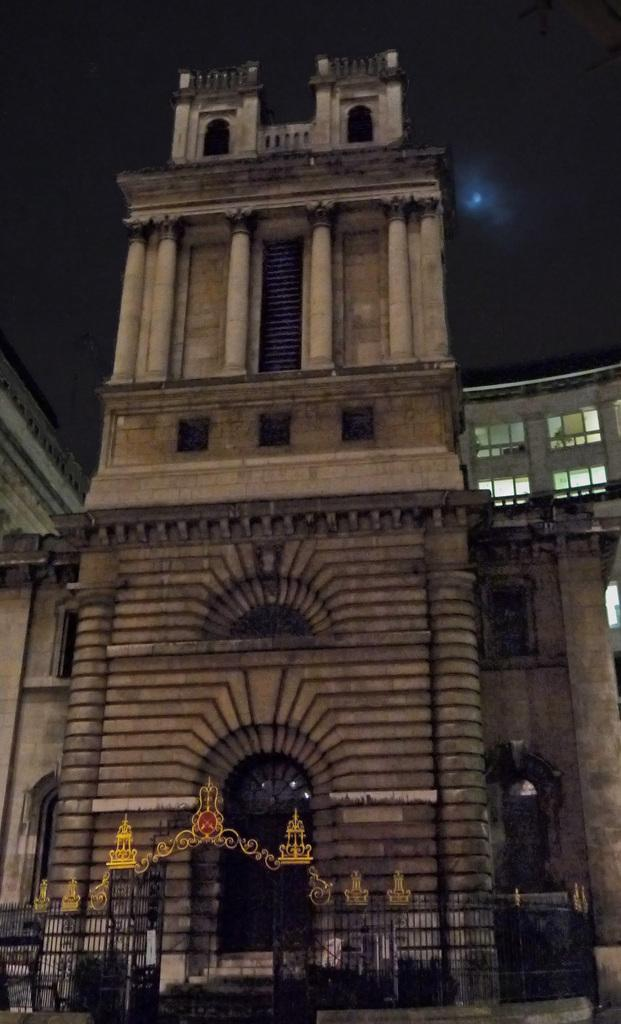What is the main subject in the center of the image? There are buildings in the center of the image. What can be seen at the bottom side of the image? There is a gate at the bottom side of the image. Can you describe the face of the man in the image? There is no man present in the image, so it is not possible to describe his face. 